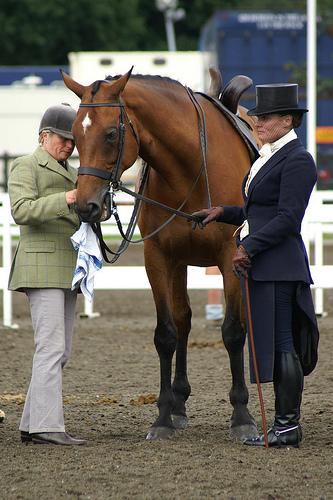What is the main, largest object in the image, and which direction is it facing? The largest object in the image is a chestnut brown horse facing towards the left side of the image. Please provide a brief description of the boots in the image, including their color and approximate size. The boots are knee-high black leather riding boots. Identify a distinct feature on the horse's head and describe its size, shape, and color. There is a white diamond-shaped spot on the horse's head. What type of pants is the woman wearing, and what color are they? The woman is wearing tan-colored horse riding pants. Describe an item the woman is holding, and give its color and measurements. The woman is holding a long brown cane. Describe the type of jacket that one of the persons is wearing, as well as its color pattern. One person is wearing a green and blue plaid jacket. What type of hat is the woman wearing, and what color is it? The woman is wearing a black top hat on her head. What are the two primary colors of the towel present in the image? The towel is blue and white in color. 